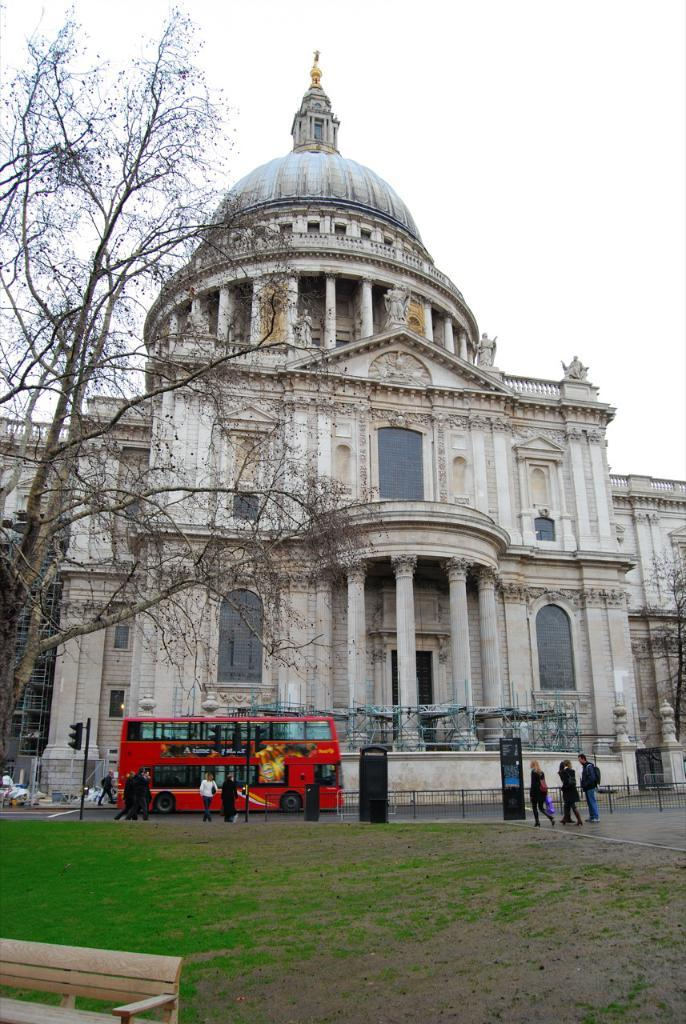What type of structure can be seen in the image? There is a building in the image. What natural elements are present in the image? There are trees and grass in the image. What mode of transportation is visible in the image? There is a vehicle in the image. Are there any living beings in the image? Yes, there are people in the image. What type of seating is available in the image? There is a bench in the image. What type of traffic control device is present in the image? There is a signal light pole in the image. What type of signage is present in the image? There is a board in the image. What type of barrier is present in the image? There is a railing in the image. What part of the natural environment is visible in the image? The sky is visible in the image. Can you describe the general setting of the image? The image features a building, trees, grass, a vehicle, people, a bench, a signal light pole, a board, a railing, and the sky. What type of humor can be seen in the image? There is no humor present in the image; it is a scene featuring a building, trees, grass, a vehicle, people, a bench, a signal light pole, a board, a railing, and the sky. What type of magic is being performed in the image? There is no magic present in the image; it is a scene featuring a building, trees, grass, a vehicle, people, a bench, a signal light pole, a board, a railing, and the sky. 